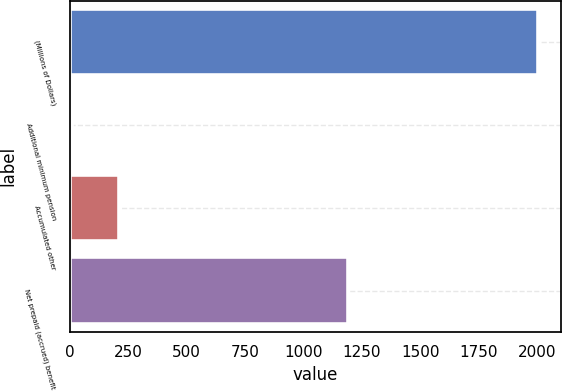<chart> <loc_0><loc_0><loc_500><loc_500><bar_chart><fcel>(Millions of Dollars)<fcel>Additional minimum pension<fcel>Accumulated other<fcel>Net prepaid (accrued) benefit<nl><fcel>2003<fcel>11<fcel>210.2<fcel>1190<nl></chart> 